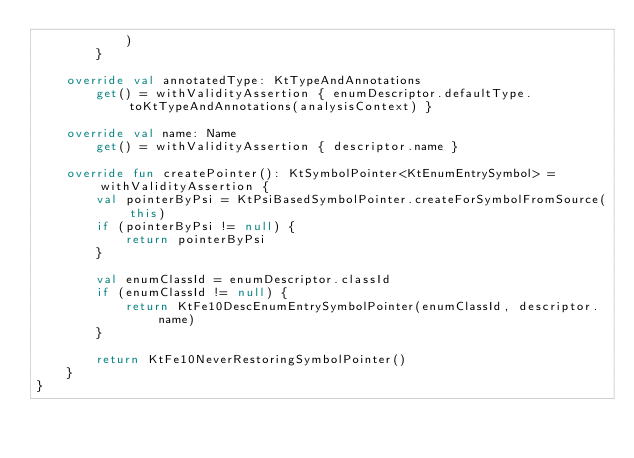Convert code to text. <code><loc_0><loc_0><loc_500><loc_500><_Kotlin_>            )
        }

    override val annotatedType: KtTypeAndAnnotations
        get() = withValidityAssertion { enumDescriptor.defaultType.toKtTypeAndAnnotations(analysisContext) }

    override val name: Name
        get() = withValidityAssertion { descriptor.name }

    override fun createPointer(): KtSymbolPointer<KtEnumEntrySymbol> = withValidityAssertion {
        val pointerByPsi = KtPsiBasedSymbolPointer.createForSymbolFromSource(this)
        if (pointerByPsi != null) {
            return pointerByPsi
        }

        val enumClassId = enumDescriptor.classId
        if (enumClassId != null) {
            return KtFe10DescEnumEntrySymbolPointer(enumClassId, descriptor.name)
        }

        return KtFe10NeverRestoringSymbolPointer()
    }
}</code> 